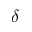Convert formula to latex. <formula><loc_0><loc_0><loc_500><loc_500>\delta</formula> 